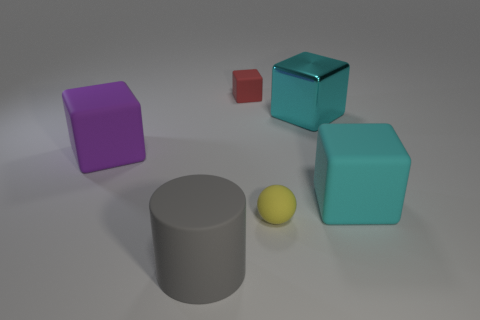Is there another large rubber thing that has the same shape as the big purple thing?
Make the answer very short. Yes. How many tiny gray balls are there?
Provide a short and direct response. 0. What is the shape of the red thing?
Your answer should be very brief. Cube. How many red cubes have the same size as the cyan rubber object?
Your answer should be compact. 0. Does the small red thing have the same shape as the gray matte thing?
Keep it short and to the point. No. There is a tiny rubber thing in front of the rubber cube right of the yellow thing; what is its color?
Your response must be concise. Yellow. There is a thing that is both to the left of the small sphere and in front of the cyan matte thing; what is its size?
Ensure brevity in your answer.  Large. Are there any other things that are the same color as the big rubber cylinder?
Offer a terse response. No. There is a cyan thing that is the same material as the small sphere; what is its shape?
Offer a terse response. Cube. There is a big purple thing; does it have the same shape as the large cyan metallic thing that is behind the tiny rubber ball?
Your response must be concise. Yes. 